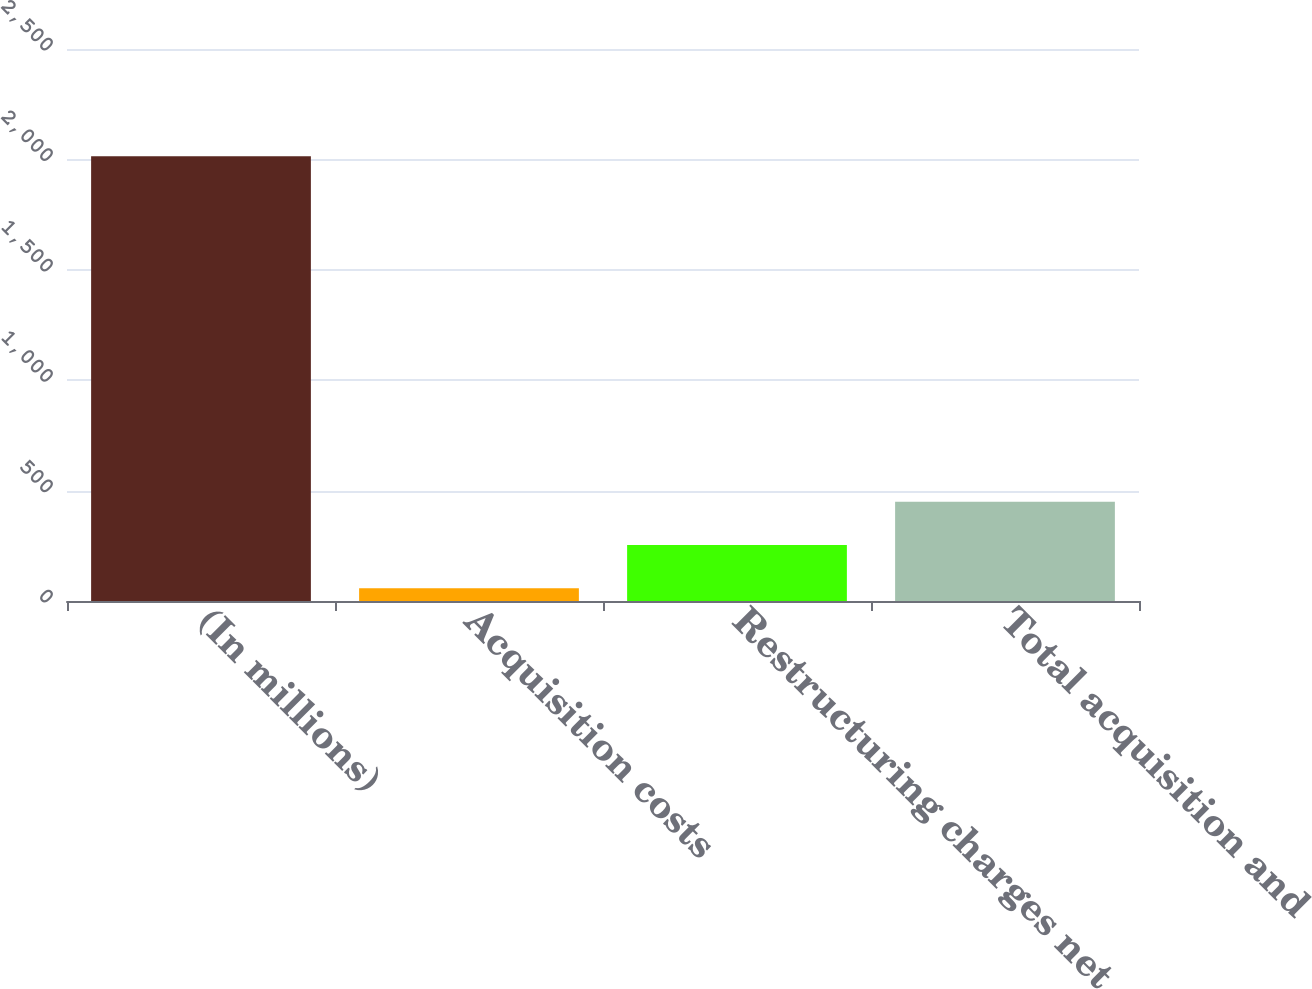Convert chart. <chart><loc_0><loc_0><loc_500><loc_500><bar_chart><fcel>(In millions)<fcel>Acquisition costs<fcel>Restructuring charges net<fcel>Total acquisition and<nl><fcel>2014<fcel>58<fcel>253.6<fcel>449.2<nl></chart> 